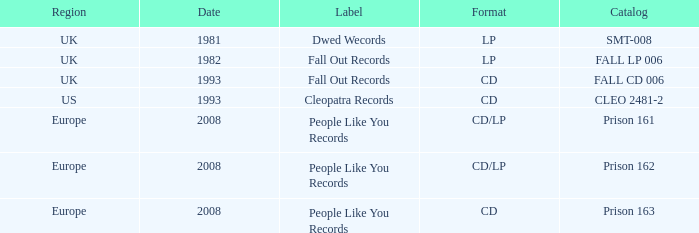Which Format has a Date of 1993, and a Catalog of cleo 2481-2? CD. 